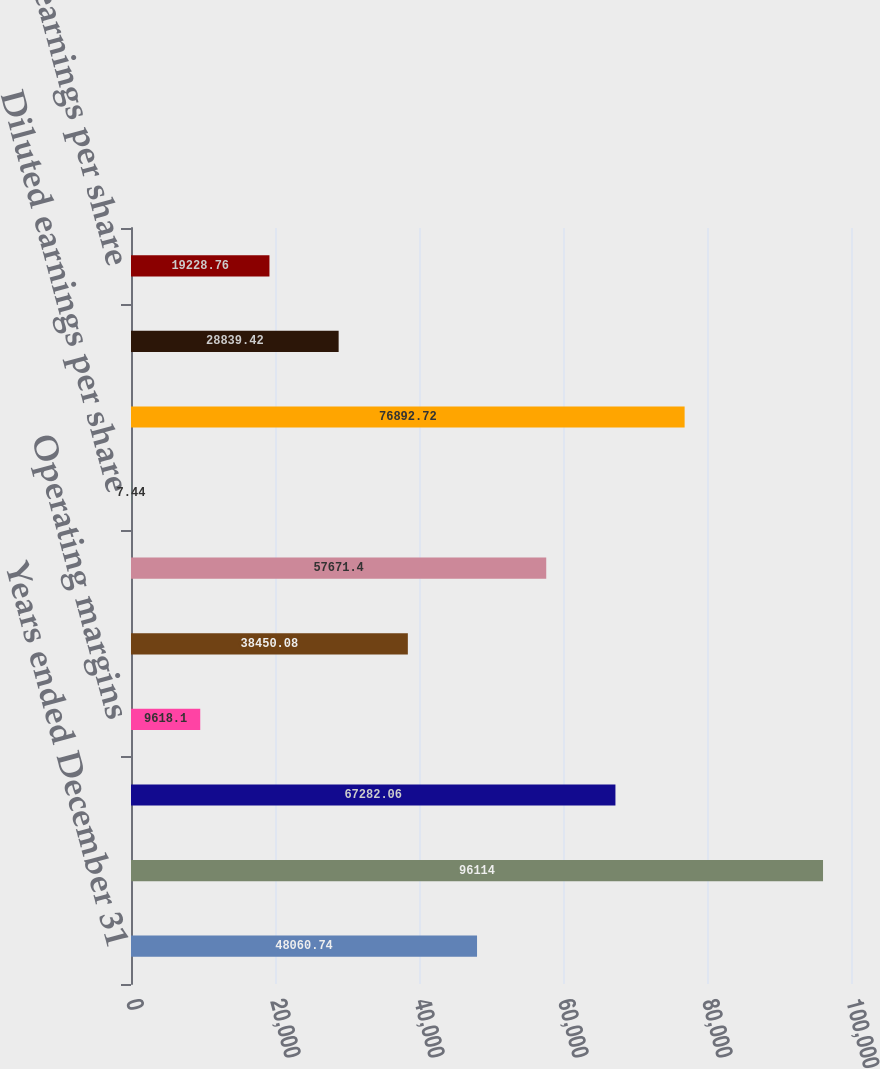<chart> <loc_0><loc_0><loc_500><loc_500><bar_chart><fcel>Years ended December 31<fcel>Revenues<fcel>Earnings from operations<fcel>Operating margins<fcel>Effective income tax rate<fcel>Net earnings<fcel>Diluted earnings per share<fcel>Core operating earnings<fcel>Core operating margins<fcel>Core earnings per share<nl><fcel>48060.7<fcel>96114<fcel>67282.1<fcel>9618.1<fcel>38450.1<fcel>57671.4<fcel>7.44<fcel>76892.7<fcel>28839.4<fcel>19228.8<nl></chart> 